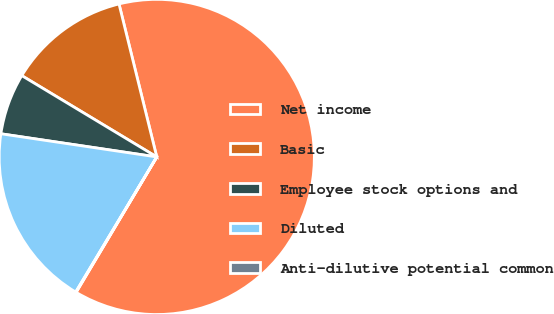<chart> <loc_0><loc_0><loc_500><loc_500><pie_chart><fcel>Net income<fcel>Basic<fcel>Employee stock options and<fcel>Diluted<fcel>Anti-dilutive potential common<nl><fcel>62.4%<fcel>12.52%<fcel>6.28%<fcel>18.75%<fcel>0.05%<nl></chart> 